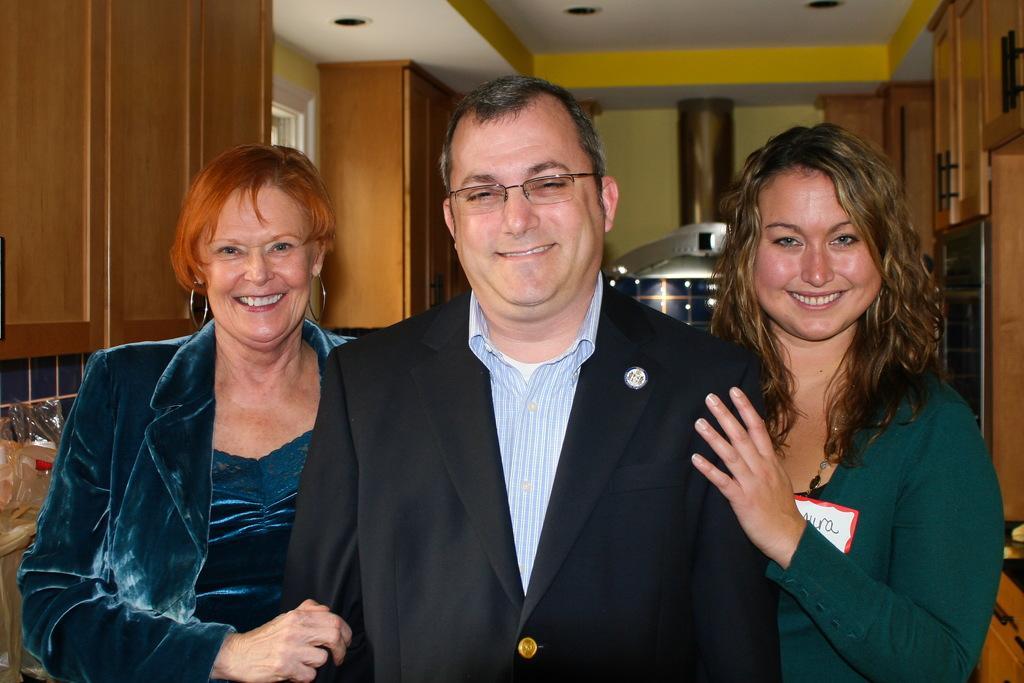Could you give a brief overview of what you see in this image? In this image one man and two women ,three are smiling ,at the top I can see the roof building and the wall. 